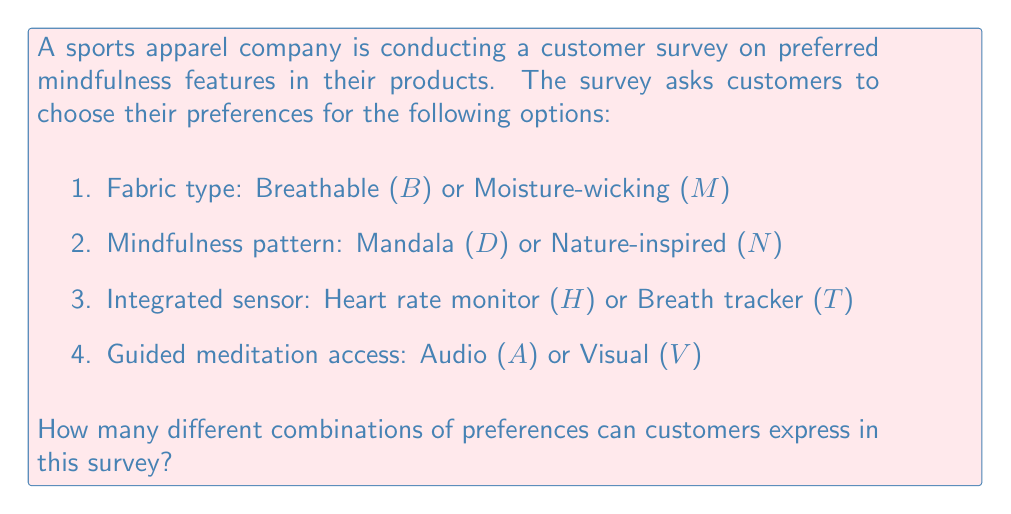Can you solve this math problem? To solve this problem, we can use the multiplication principle of counting. For each feature, we count the number of options available and then multiply these counts together.

1. Fabric type: 2 options ($B$ or $M$)
2. Mindfulness pattern: 2 options ($D$ or $N$)
3. Integrated sensor: 2 options ($H$ or $T$)
4. Guided meditation access: 2 options ($A$ or $V$)

For each feature, a customer must choose exactly one option. The total number of possible combinations is therefore:

$$ \text{Total combinations} = 2 \times 2 \times 2 \times 2 $$

This can also be written as:

$$ \text{Total combinations} = 2^4 $$

Calculating this:

$$ 2^4 = 2 \times 2 \times 2 \times 2 = 16 $$

Therefore, there are 16 different possible combinations of preferences that customers can express in this survey.
Answer: 16 combinations 